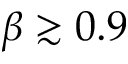<formula> <loc_0><loc_0><loc_500><loc_500>\beta \gtrsim 0 . 9</formula> 